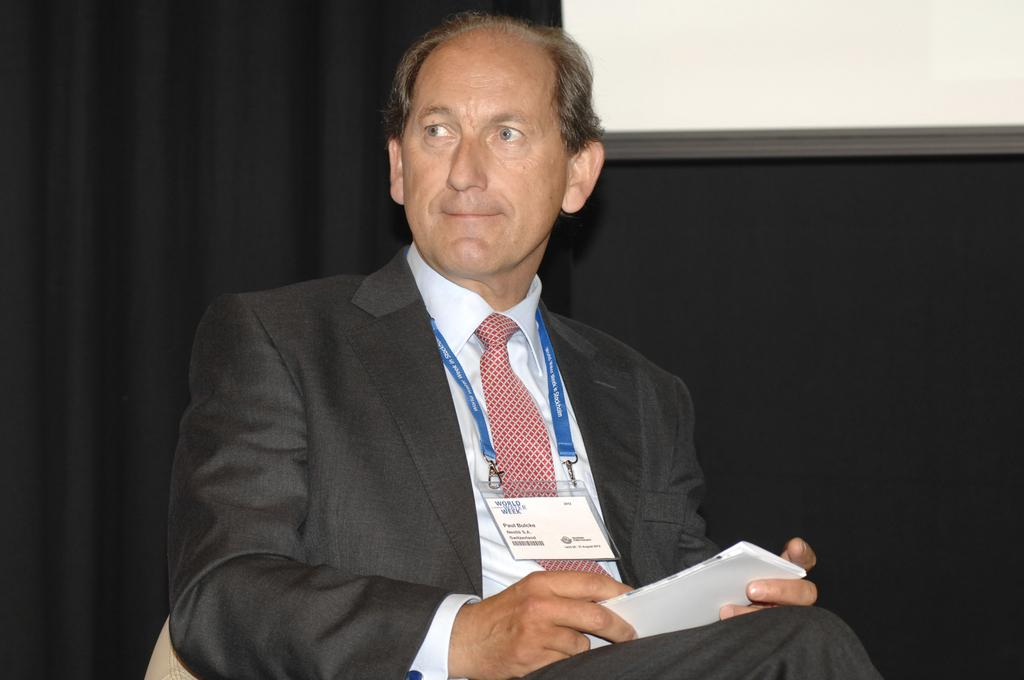What can be seen in the image? There is a person in the image. What is the person wearing? The person is wearing a coat and a tie. Does the person have any identification? Yes, the person has an ID card. What is the person holding in their hand? The person is holding a paper in their hand. What is visible in the background of the image? There is a black screen in the background of the image. What books is the person reading in the image? There are no books visible in the image. Is the person driving a vehicle in the image? There is no vehicle or driving activity depicted in the image. 